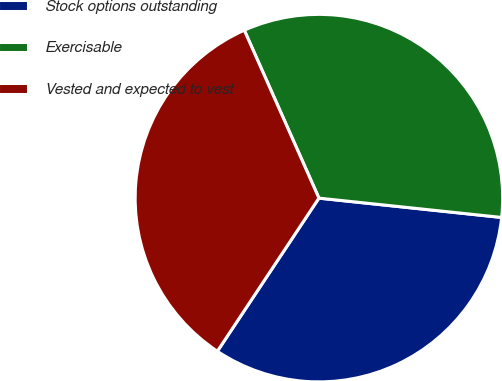Convert chart. <chart><loc_0><loc_0><loc_500><loc_500><pie_chart><fcel>Stock options outstanding<fcel>Exercisable<fcel>Vested and expected to vest<nl><fcel>32.64%<fcel>33.33%<fcel>34.02%<nl></chart> 